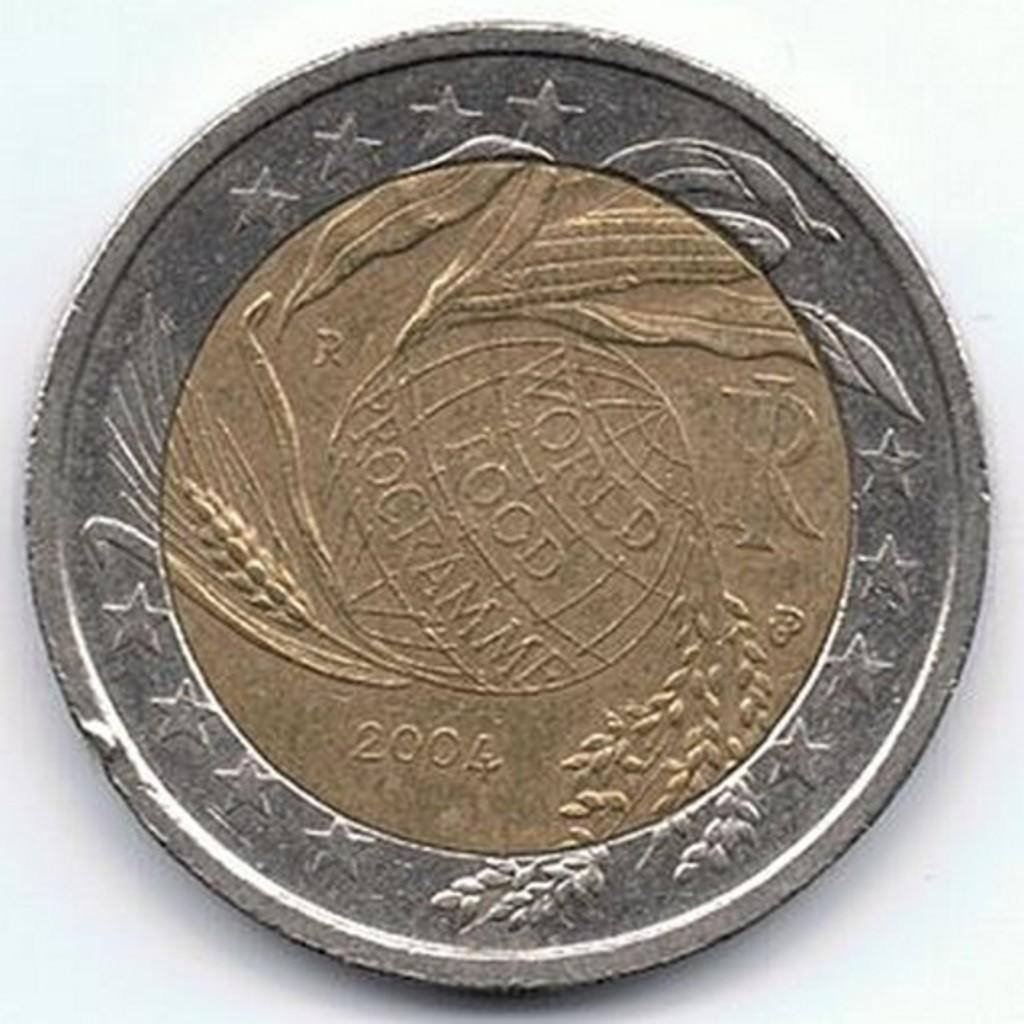<image>
Summarize the visual content of the image. A silver and gold coin that has the word "world" on it. 